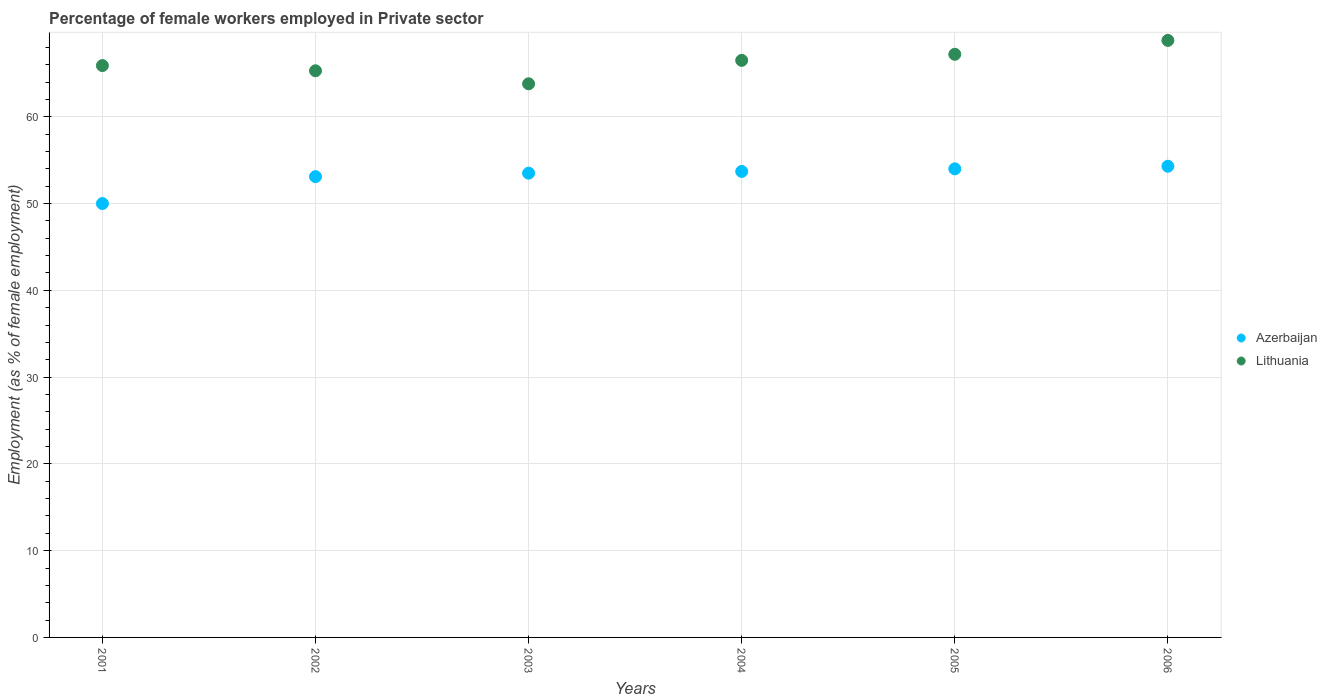How many different coloured dotlines are there?
Provide a short and direct response. 2. Is the number of dotlines equal to the number of legend labels?
Provide a short and direct response. Yes. What is the percentage of females employed in Private sector in Azerbaijan in 2004?
Keep it short and to the point. 53.7. Across all years, what is the maximum percentage of females employed in Private sector in Azerbaijan?
Offer a terse response. 54.3. In which year was the percentage of females employed in Private sector in Lithuania maximum?
Provide a short and direct response. 2006. In which year was the percentage of females employed in Private sector in Azerbaijan minimum?
Your answer should be compact. 2001. What is the total percentage of females employed in Private sector in Azerbaijan in the graph?
Ensure brevity in your answer.  318.6. What is the difference between the percentage of females employed in Private sector in Lithuania in 2002 and that in 2006?
Offer a very short reply. -3.5. What is the difference between the percentage of females employed in Private sector in Azerbaijan in 2006 and the percentage of females employed in Private sector in Lithuania in 2004?
Offer a terse response. -12.2. What is the average percentage of females employed in Private sector in Azerbaijan per year?
Keep it short and to the point. 53.1. In the year 2002, what is the difference between the percentage of females employed in Private sector in Azerbaijan and percentage of females employed in Private sector in Lithuania?
Provide a short and direct response. -12.2. What is the ratio of the percentage of females employed in Private sector in Azerbaijan in 2001 to that in 2006?
Give a very brief answer. 0.92. Is the difference between the percentage of females employed in Private sector in Azerbaijan in 2002 and 2005 greater than the difference between the percentage of females employed in Private sector in Lithuania in 2002 and 2005?
Make the answer very short. Yes. What is the difference between the highest and the second highest percentage of females employed in Private sector in Lithuania?
Offer a terse response. 1.6. What is the difference between the highest and the lowest percentage of females employed in Private sector in Azerbaijan?
Keep it short and to the point. 4.3. In how many years, is the percentage of females employed in Private sector in Lithuania greater than the average percentage of females employed in Private sector in Lithuania taken over all years?
Offer a terse response. 3. Does the percentage of females employed in Private sector in Azerbaijan monotonically increase over the years?
Give a very brief answer. Yes. Is the percentage of females employed in Private sector in Lithuania strictly greater than the percentage of females employed in Private sector in Azerbaijan over the years?
Ensure brevity in your answer.  Yes. Is the percentage of females employed in Private sector in Lithuania strictly less than the percentage of females employed in Private sector in Azerbaijan over the years?
Make the answer very short. No. How many years are there in the graph?
Your answer should be very brief. 6. Does the graph contain any zero values?
Make the answer very short. No. Does the graph contain grids?
Give a very brief answer. Yes. Where does the legend appear in the graph?
Offer a terse response. Center right. How many legend labels are there?
Provide a short and direct response. 2. How are the legend labels stacked?
Ensure brevity in your answer.  Vertical. What is the title of the graph?
Your answer should be very brief. Percentage of female workers employed in Private sector. Does "Central African Republic" appear as one of the legend labels in the graph?
Your answer should be compact. No. What is the label or title of the Y-axis?
Your answer should be compact. Employment (as % of female employment). What is the Employment (as % of female employment) in Azerbaijan in 2001?
Your answer should be compact. 50. What is the Employment (as % of female employment) of Lithuania in 2001?
Keep it short and to the point. 65.9. What is the Employment (as % of female employment) in Azerbaijan in 2002?
Keep it short and to the point. 53.1. What is the Employment (as % of female employment) of Lithuania in 2002?
Offer a terse response. 65.3. What is the Employment (as % of female employment) in Azerbaijan in 2003?
Your response must be concise. 53.5. What is the Employment (as % of female employment) of Lithuania in 2003?
Your answer should be compact. 63.8. What is the Employment (as % of female employment) in Azerbaijan in 2004?
Provide a succinct answer. 53.7. What is the Employment (as % of female employment) in Lithuania in 2004?
Keep it short and to the point. 66.5. What is the Employment (as % of female employment) in Lithuania in 2005?
Your answer should be compact. 67.2. What is the Employment (as % of female employment) of Azerbaijan in 2006?
Your answer should be compact. 54.3. What is the Employment (as % of female employment) in Lithuania in 2006?
Make the answer very short. 68.8. Across all years, what is the maximum Employment (as % of female employment) in Azerbaijan?
Offer a terse response. 54.3. Across all years, what is the maximum Employment (as % of female employment) of Lithuania?
Offer a very short reply. 68.8. Across all years, what is the minimum Employment (as % of female employment) of Lithuania?
Provide a succinct answer. 63.8. What is the total Employment (as % of female employment) of Azerbaijan in the graph?
Ensure brevity in your answer.  318.6. What is the total Employment (as % of female employment) in Lithuania in the graph?
Your answer should be very brief. 397.5. What is the difference between the Employment (as % of female employment) in Azerbaijan in 2001 and that in 2002?
Provide a short and direct response. -3.1. What is the difference between the Employment (as % of female employment) in Azerbaijan in 2001 and that in 2003?
Provide a succinct answer. -3.5. What is the difference between the Employment (as % of female employment) of Lithuania in 2001 and that in 2003?
Your answer should be very brief. 2.1. What is the difference between the Employment (as % of female employment) in Azerbaijan in 2001 and that in 2004?
Your response must be concise. -3.7. What is the difference between the Employment (as % of female employment) in Azerbaijan in 2001 and that in 2005?
Offer a very short reply. -4. What is the difference between the Employment (as % of female employment) of Lithuania in 2001 and that in 2005?
Offer a very short reply. -1.3. What is the difference between the Employment (as % of female employment) in Azerbaijan in 2002 and that in 2004?
Keep it short and to the point. -0.6. What is the difference between the Employment (as % of female employment) of Azerbaijan in 2003 and that in 2004?
Your answer should be very brief. -0.2. What is the difference between the Employment (as % of female employment) in Lithuania in 2003 and that in 2006?
Your answer should be very brief. -5. What is the difference between the Employment (as % of female employment) of Azerbaijan in 2004 and that in 2005?
Make the answer very short. -0.3. What is the difference between the Employment (as % of female employment) of Lithuania in 2004 and that in 2005?
Offer a very short reply. -0.7. What is the difference between the Employment (as % of female employment) in Azerbaijan in 2004 and that in 2006?
Offer a very short reply. -0.6. What is the difference between the Employment (as % of female employment) of Lithuania in 2005 and that in 2006?
Offer a terse response. -1.6. What is the difference between the Employment (as % of female employment) in Azerbaijan in 2001 and the Employment (as % of female employment) in Lithuania in 2002?
Give a very brief answer. -15.3. What is the difference between the Employment (as % of female employment) in Azerbaijan in 2001 and the Employment (as % of female employment) in Lithuania in 2003?
Keep it short and to the point. -13.8. What is the difference between the Employment (as % of female employment) of Azerbaijan in 2001 and the Employment (as % of female employment) of Lithuania in 2004?
Offer a very short reply. -16.5. What is the difference between the Employment (as % of female employment) of Azerbaijan in 2001 and the Employment (as % of female employment) of Lithuania in 2005?
Your response must be concise. -17.2. What is the difference between the Employment (as % of female employment) of Azerbaijan in 2001 and the Employment (as % of female employment) of Lithuania in 2006?
Offer a very short reply. -18.8. What is the difference between the Employment (as % of female employment) of Azerbaijan in 2002 and the Employment (as % of female employment) of Lithuania in 2004?
Keep it short and to the point. -13.4. What is the difference between the Employment (as % of female employment) in Azerbaijan in 2002 and the Employment (as % of female employment) in Lithuania in 2005?
Provide a succinct answer. -14.1. What is the difference between the Employment (as % of female employment) in Azerbaijan in 2002 and the Employment (as % of female employment) in Lithuania in 2006?
Provide a short and direct response. -15.7. What is the difference between the Employment (as % of female employment) in Azerbaijan in 2003 and the Employment (as % of female employment) in Lithuania in 2005?
Provide a succinct answer. -13.7. What is the difference between the Employment (as % of female employment) in Azerbaijan in 2003 and the Employment (as % of female employment) in Lithuania in 2006?
Give a very brief answer. -15.3. What is the difference between the Employment (as % of female employment) of Azerbaijan in 2004 and the Employment (as % of female employment) of Lithuania in 2005?
Offer a very short reply. -13.5. What is the difference between the Employment (as % of female employment) in Azerbaijan in 2004 and the Employment (as % of female employment) in Lithuania in 2006?
Your answer should be very brief. -15.1. What is the difference between the Employment (as % of female employment) of Azerbaijan in 2005 and the Employment (as % of female employment) of Lithuania in 2006?
Your answer should be compact. -14.8. What is the average Employment (as % of female employment) in Azerbaijan per year?
Make the answer very short. 53.1. What is the average Employment (as % of female employment) of Lithuania per year?
Offer a very short reply. 66.25. In the year 2001, what is the difference between the Employment (as % of female employment) in Azerbaijan and Employment (as % of female employment) in Lithuania?
Offer a very short reply. -15.9. In the year 2002, what is the difference between the Employment (as % of female employment) in Azerbaijan and Employment (as % of female employment) in Lithuania?
Offer a terse response. -12.2. What is the ratio of the Employment (as % of female employment) of Azerbaijan in 2001 to that in 2002?
Offer a very short reply. 0.94. What is the ratio of the Employment (as % of female employment) of Lithuania in 2001 to that in 2002?
Provide a short and direct response. 1.01. What is the ratio of the Employment (as % of female employment) in Azerbaijan in 2001 to that in 2003?
Offer a terse response. 0.93. What is the ratio of the Employment (as % of female employment) in Lithuania in 2001 to that in 2003?
Provide a short and direct response. 1.03. What is the ratio of the Employment (as % of female employment) in Azerbaijan in 2001 to that in 2004?
Ensure brevity in your answer.  0.93. What is the ratio of the Employment (as % of female employment) in Azerbaijan in 2001 to that in 2005?
Ensure brevity in your answer.  0.93. What is the ratio of the Employment (as % of female employment) of Lithuania in 2001 to that in 2005?
Your response must be concise. 0.98. What is the ratio of the Employment (as % of female employment) in Azerbaijan in 2001 to that in 2006?
Give a very brief answer. 0.92. What is the ratio of the Employment (as % of female employment) of Lithuania in 2001 to that in 2006?
Ensure brevity in your answer.  0.96. What is the ratio of the Employment (as % of female employment) of Azerbaijan in 2002 to that in 2003?
Your response must be concise. 0.99. What is the ratio of the Employment (as % of female employment) in Lithuania in 2002 to that in 2003?
Provide a short and direct response. 1.02. What is the ratio of the Employment (as % of female employment) in Azerbaijan in 2002 to that in 2004?
Your answer should be very brief. 0.99. What is the ratio of the Employment (as % of female employment) of Azerbaijan in 2002 to that in 2005?
Provide a succinct answer. 0.98. What is the ratio of the Employment (as % of female employment) in Lithuania in 2002 to that in 2005?
Ensure brevity in your answer.  0.97. What is the ratio of the Employment (as % of female employment) in Azerbaijan in 2002 to that in 2006?
Make the answer very short. 0.98. What is the ratio of the Employment (as % of female employment) of Lithuania in 2002 to that in 2006?
Give a very brief answer. 0.95. What is the ratio of the Employment (as % of female employment) of Lithuania in 2003 to that in 2004?
Provide a short and direct response. 0.96. What is the ratio of the Employment (as % of female employment) in Lithuania in 2003 to that in 2005?
Give a very brief answer. 0.95. What is the ratio of the Employment (as % of female employment) in Lithuania in 2003 to that in 2006?
Provide a short and direct response. 0.93. What is the ratio of the Employment (as % of female employment) of Azerbaijan in 2004 to that in 2006?
Make the answer very short. 0.99. What is the ratio of the Employment (as % of female employment) of Lithuania in 2004 to that in 2006?
Give a very brief answer. 0.97. What is the ratio of the Employment (as % of female employment) in Azerbaijan in 2005 to that in 2006?
Make the answer very short. 0.99. What is the ratio of the Employment (as % of female employment) in Lithuania in 2005 to that in 2006?
Offer a very short reply. 0.98. What is the difference between the highest and the second highest Employment (as % of female employment) in Azerbaijan?
Give a very brief answer. 0.3. What is the difference between the highest and the second highest Employment (as % of female employment) of Lithuania?
Keep it short and to the point. 1.6. What is the difference between the highest and the lowest Employment (as % of female employment) in Azerbaijan?
Make the answer very short. 4.3. What is the difference between the highest and the lowest Employment (as % of female employment) in Lithuania?
Offer a terse response. 5. 